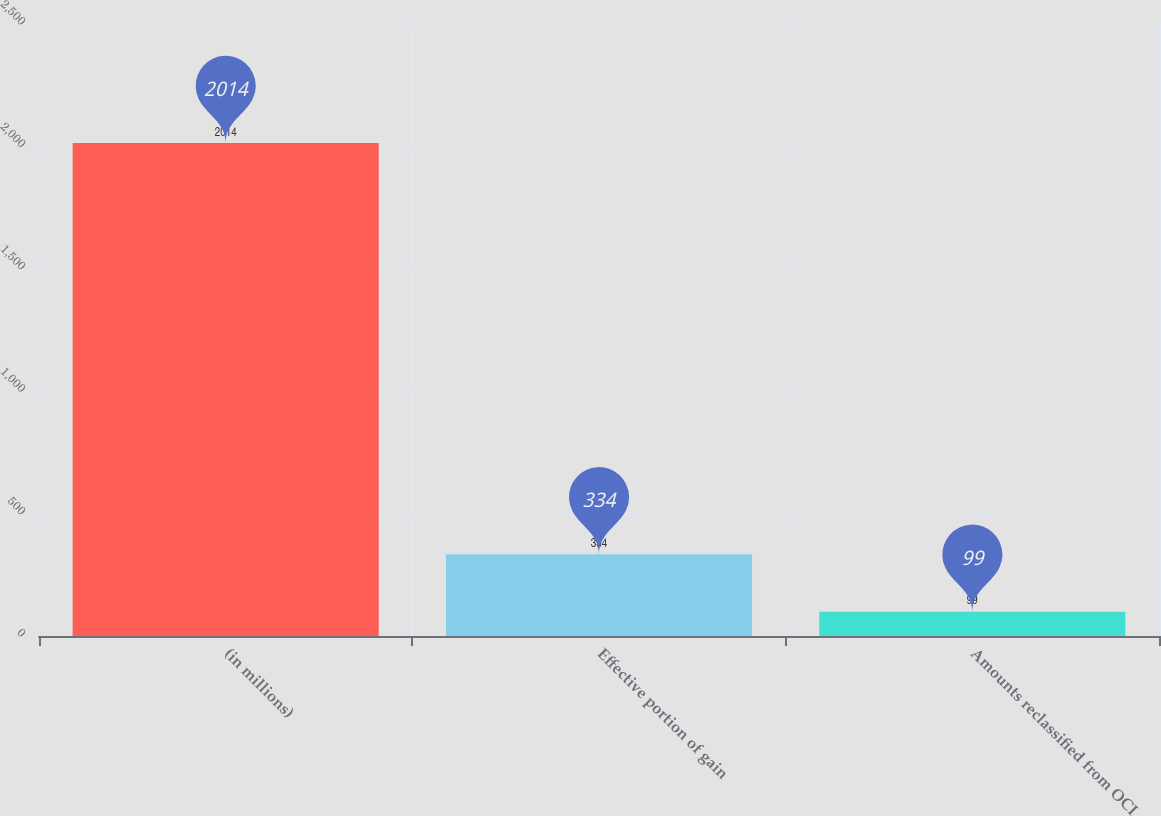<chart> <loc_0><loc_0><loc_500><loc_500><bar_chart><fcel>(in millions)<fcel>Effective portion of gain<fcel>Amounts reclassified from OCI<nl><fcel>2014<fcel>334<fcel>99<nl></chart> 